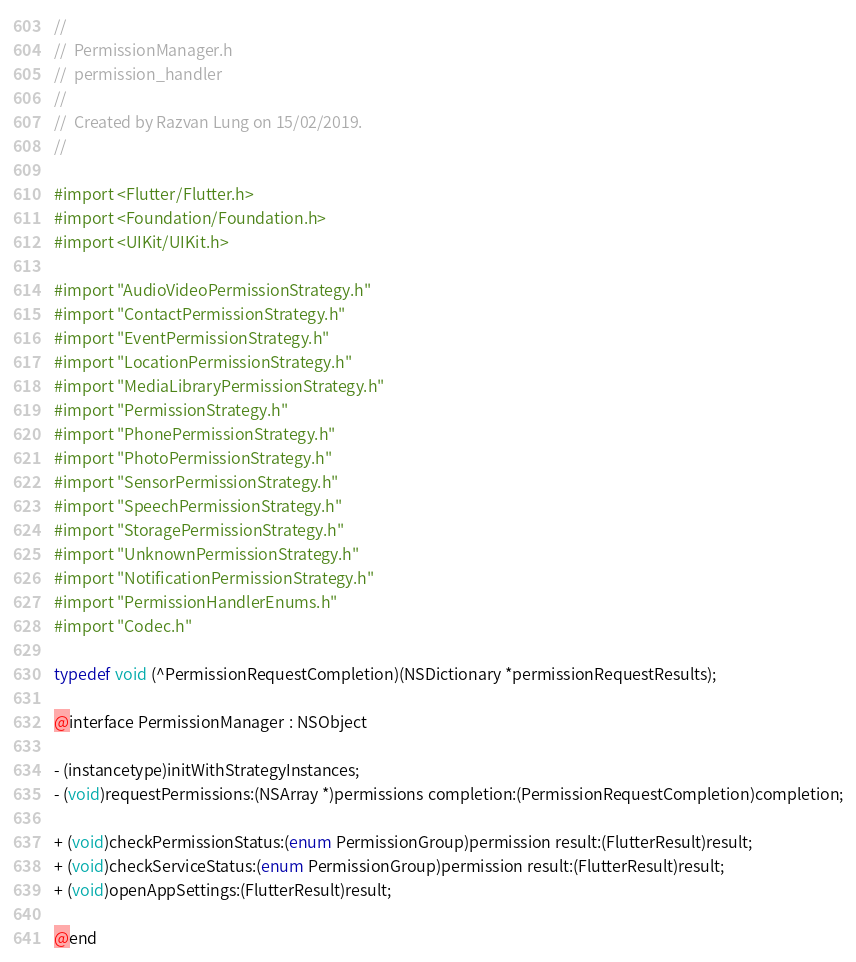<code> <loc_0><loc_0><loc_500><loc_500><_C_>//
//  PermissionManager.h
//  permission_handler
//
//  Created by Razvan Lung on 15/02/2019.
//

#import <Flutter/Flutter.h>
#import <Foundation/Foundation.h>
#import <UIKit/UIKit.h>

#import "AudioVideoPermissionStrategy.h"
#import "ContactPermissionStrategy.h"
#import "EventPermissionStrategy.h"
#import "LocationPermissionStrategy.h"
#import "MediaLibraryPermissionStrategy.h"
#import "PermissionStrategy.h"
#import "PhonePermissionStrategy.h"
#import "PhotoPermissionStrategy.h"
#import "SensorPermissionStrategy.h"
#import "SpeechPermissionStrategy.h"
#import "StoragePermissionStrategy.h"
#import "UnknownPermissionStrategy.h"
#import "NotificationPermissionStrategy.h"
#import "PermissionHandlerEnums.h"
#import "Codec.h"

typedef void (^PermissionRequestCompletion)(NSDictionary *permissionRequestResults);

@interface PermissionManager : NSObject

- (instancetype)initWithStrategyInstances;
- (void)requestPermissions:(NSArray *)permissions completion:(PermissionRequestCompletion)completion;

+ (void)checkPermissionStatus:(enum PermissionGroup)permission result:(FlutterResult)result;
+ (void)checkServiceStatus:(enum PermissionGroup)permission result:(FlutterResult)result;
+ (void)openAppSettings:(FlutterResult)result;

@end
</code> 